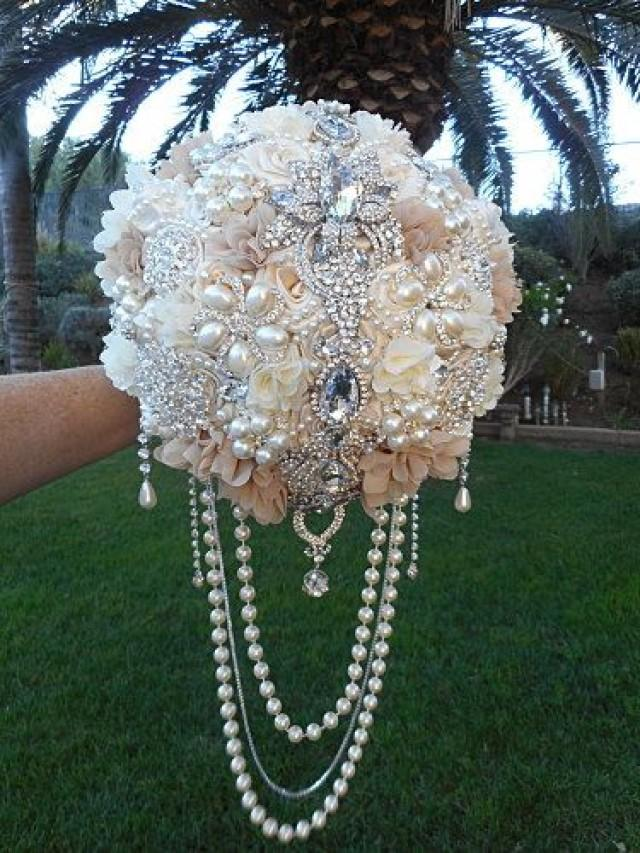How might the weight and size of this bouquet impact the bride's experience? The substantial weight and size of the bouquet could pose a challenge for the bride, particularly over a lengthy period, such as during a ceremony or while taking photographs. To mitigate discomfort, the bride might opt to hold the bouquet for only the most important parts of the event or have a less elaborate version for longer periods. It's also likely that a bouquet of this nature would be specifically designed with the bride's ability to comfortably carry it in mind, balancing visual impact with practicality. 